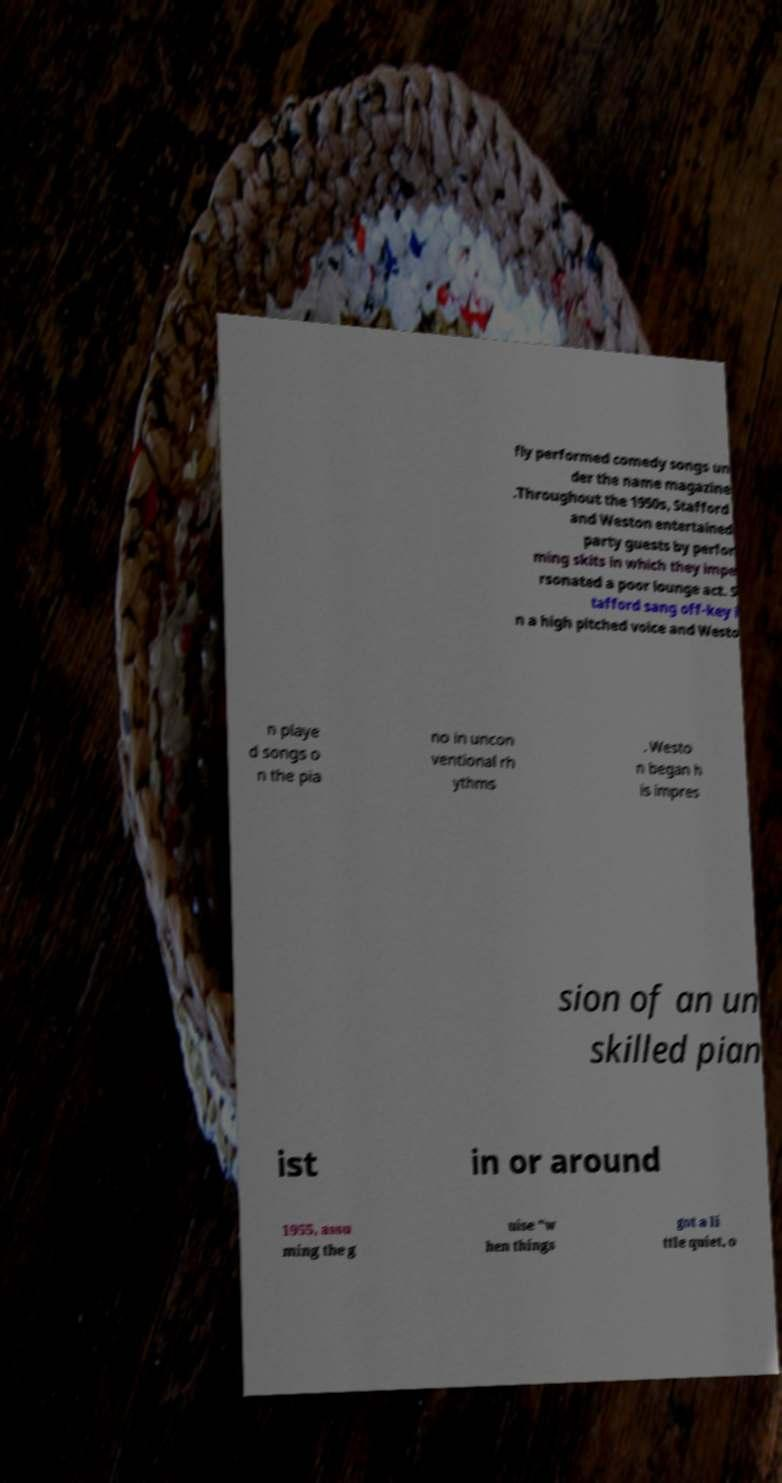What messages or text are displayed in this image? I need them in a readable, typed format. fly performed comedy songs un der the name magazine .Throughout the 1950s, Stafford and Weston entertained party guests by perfor ming skits in which they impe rsonated a poor lounge act. S tafford sang off-key i n a high pitched voice and Westo n playe d songs o n the pia no in uncon ventional rh ythms . Westo n began h is impres sion of an un skilled pian ist in or around 1955, assu ming the g uise "w hen things got a li ttle quiet, o 